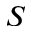<formula> <loc_0><loc_0><loc_500><loc_500>S</formula> 